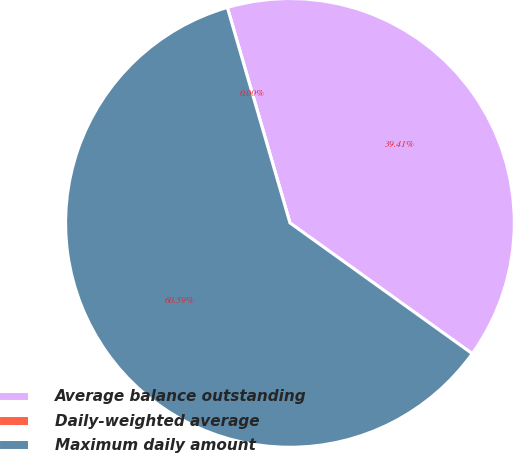<chart> <loc_0><loc_0><loc_500><loc_500><pie_chart><fcel>Average balance outstanding<fcel>Daily-weighted average<fcel>Maximum daily amount<nl><fcel>39.41%<fcel>0.0%<fcel>60.59%<nl></chart> 